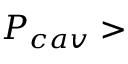Convert formula to latex. <formula><loc_0><loc_0><loc_500><loc_500>P _ { c a v } ></formula> 